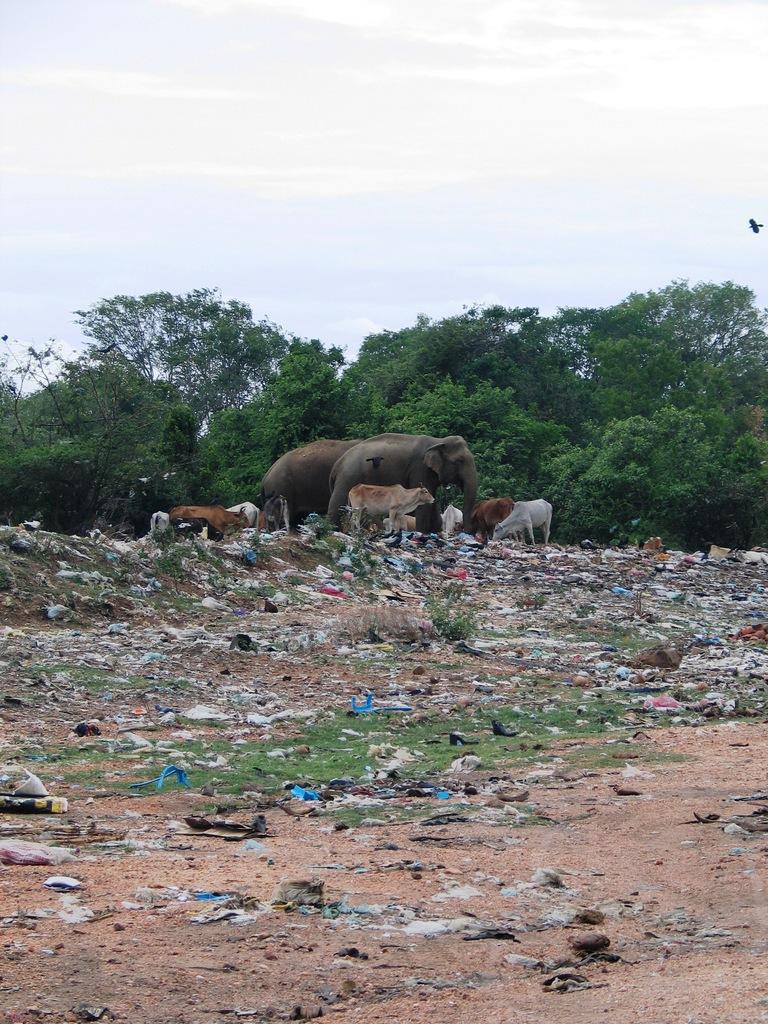Please provide a concise description of this image. In the foreground of the image we can see sand, grass and waste material. In the middle of the image we can see animals and trees. On the top of the image we can see the sky. 